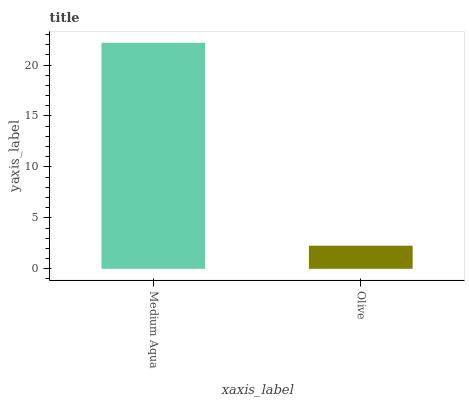Is Olive the minimum?
Answer yes or no. Yes. Is Medium Aqua the maximum?
Answer yes or no. Yes. Is Olive the maximum?
Answer yes or no. No. Is Medium Aqua greater than Olive?
Answer yes or no. Yes. Is Olive less than Medium Aqua?
Answer yes or no. Yes. Is Olive greater than Medium Aqua?
Answer yes or no. No. Is Medium Aqua less than Olive?
Answer yes or no. No. Is Medium Aqua the high median?
Answer yes or no. Yes. Is Olive the low median?
Answer yes or no. Yes. Is Olive the high median?
Answer yes or no. No. Is Medium Aqua the low median?
Answer yes or no. No. 